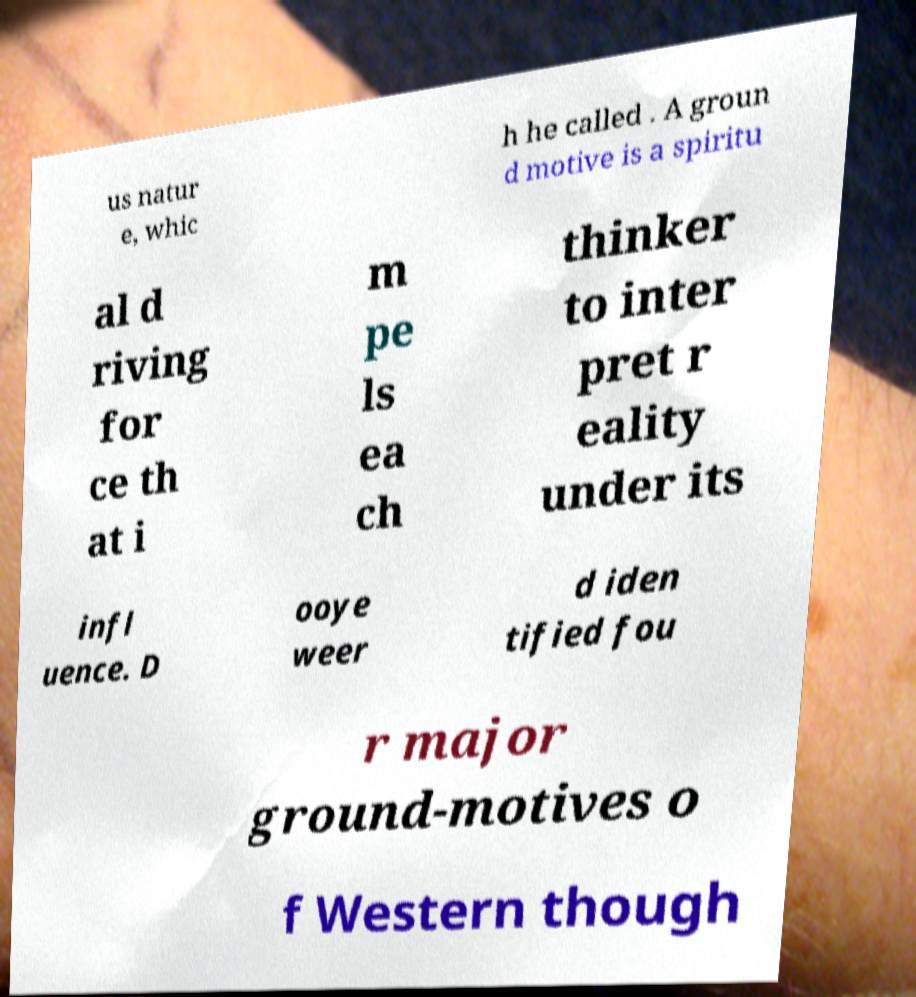Can you accurately transcribe the text from the provided image for me? us natur e, whic h he called . A groun d motive is a spiritu al d riving for ce th at i m pe ls ea ch thinker to inter pret r eality under its infl uence. D ooye weer d iden tified fou r major ground-motives o f Western though 